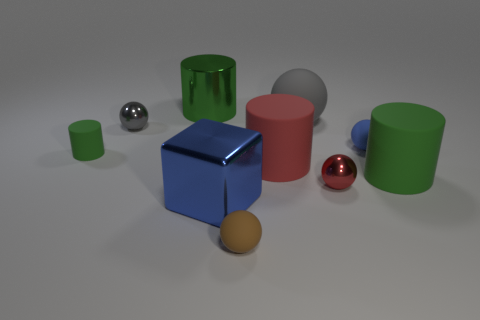Subtract all gray spheres. How many spheres are left? 3 Subtract all brown cylinders. How many gray balls are left? 2 Subtract all blue spheres. How many spheres are left? 4 Subtract all cylinders. How many objects are left? 6 Subtract 2 balls. How many balls are left? 3 Subtract 1 blue cubes. How many objects are left? 9 Subtract all cyan blocks. Subtract all purple balls. How many blocks are left? 1 Subtract all tiny green rubber objects. Subtract all green things. How many objects are left? 6 Add 5 large green metal cylinders. How many large green metal cylinders are left? 6 Add 8 red cylinders. How many red cylinders exist? 9 